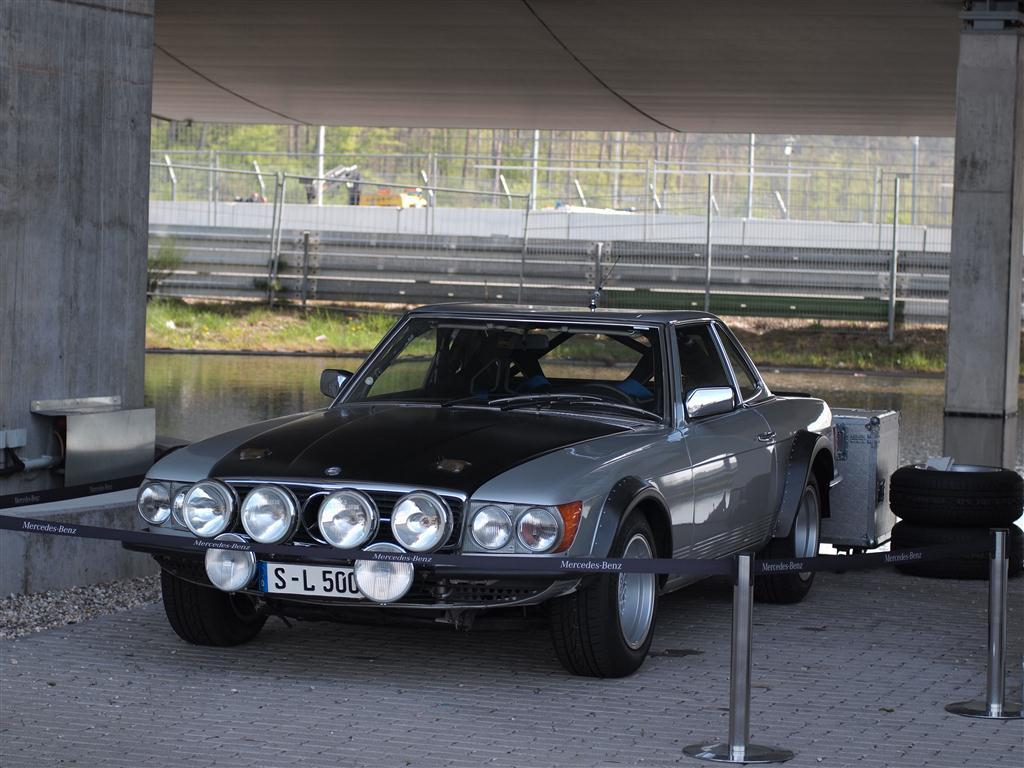What is the main subject of the image? There is a vehicle in the image. Where is the vehicle located? The vehicle is under a shelter. What can be seen beside the vehicle? There are two tires beside the vehicle. What is visible in the background of the image? There is a lake in the background of the image. What is behind the lake in the image? There is a mesh behind the lake. What type of paste is being used to hold the silver theory together in the image? There is no paste, silver, or theory present in the image. 